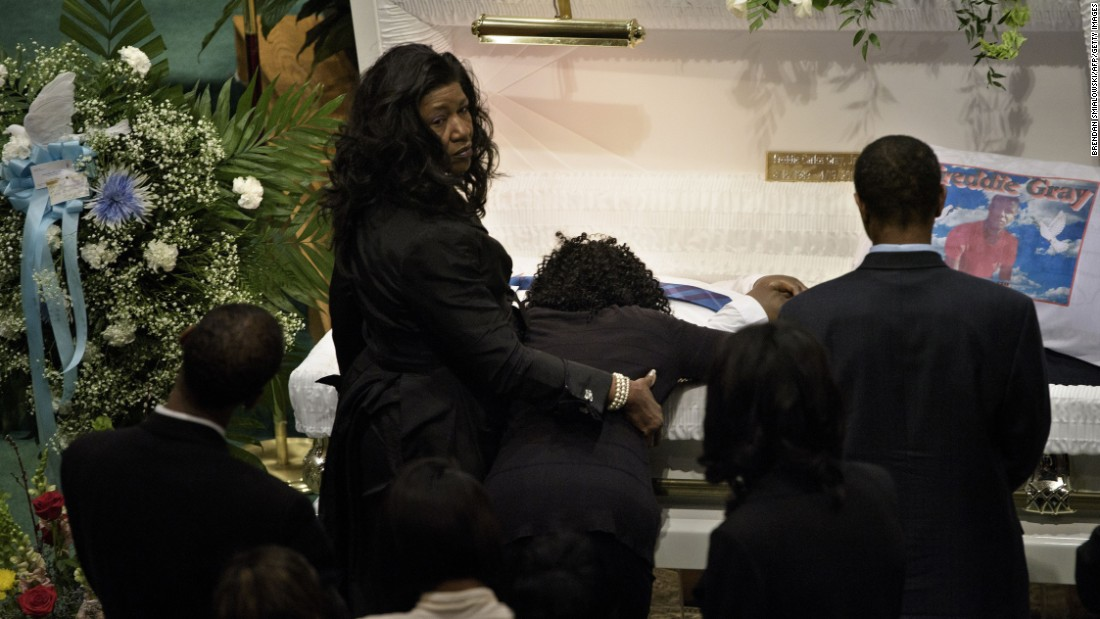What emotions might the individuals be discussing or reflecting on at this moment? The individuals are likely reflecting on a myriad of emotions ranging from deep sadness and loss to perhaps fond memories and gratitude for the life lived by the deceased. The somber mood suggests a communal processing of grief and mourning, with personal reflections likely touching on how the deceased impacted their lives. 